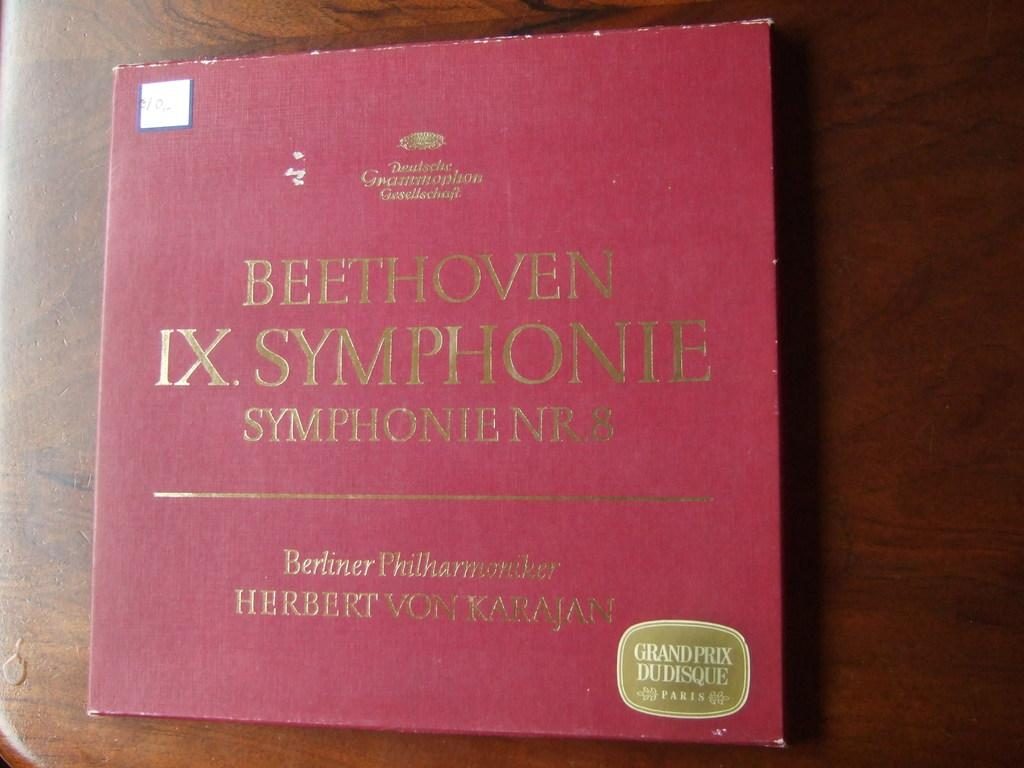<image>
Share a concise interpretation of the image provided. a book that was created from the works of Beethoven 